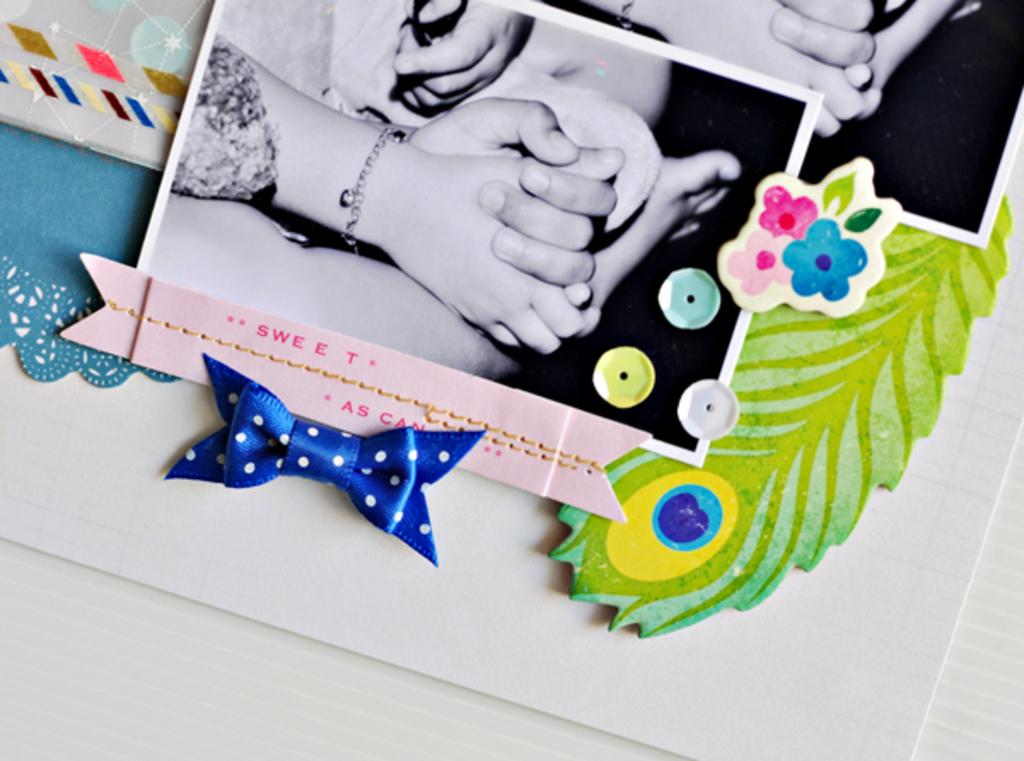What can be seen at the bottom of the image? The ground is visible in the image. What type of paper items are present in the image? There are photocopies in the image. What kind of handmade items can be seen in the image? There are crafted objects in the image. Where are the objects located in the image? There are objects on the left side of the image. Is there a key stuck in the quicksand in the image? There is no quicksand or key present in the image. Is there a gun visible on the left side of the image? There is no gun present in the image. 